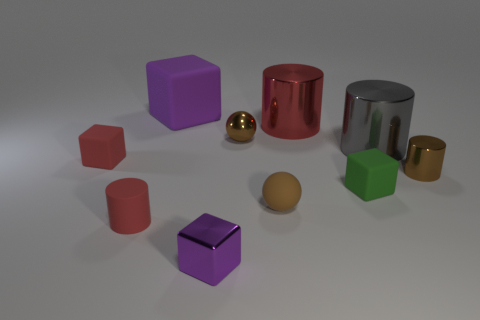Subtract all small red rubber cylinders. How many cylinders are left? 3 Subtract all red cylinders. How many cylinders are left? 2 Subtract all spheres. How many objects are left? 8 Subtract 2 cubes. How many cubes are left? 2 Subtract all purple cylinders. Subtract all cyan blocks. How many cylinders are left? 4 Subtract all green cylinders. How many green balls are left? 0 Subtract all small cyan objects. Subtract all small shiny blocks. How many objects are left? 9 Add 8 brown metal spheres. How many brown metal spheres are left? 9 Add 1 small brown shiny balls. How many small brown shiny balls exist? 2 Subtract 1 red cubes. How many objects are left? 9 